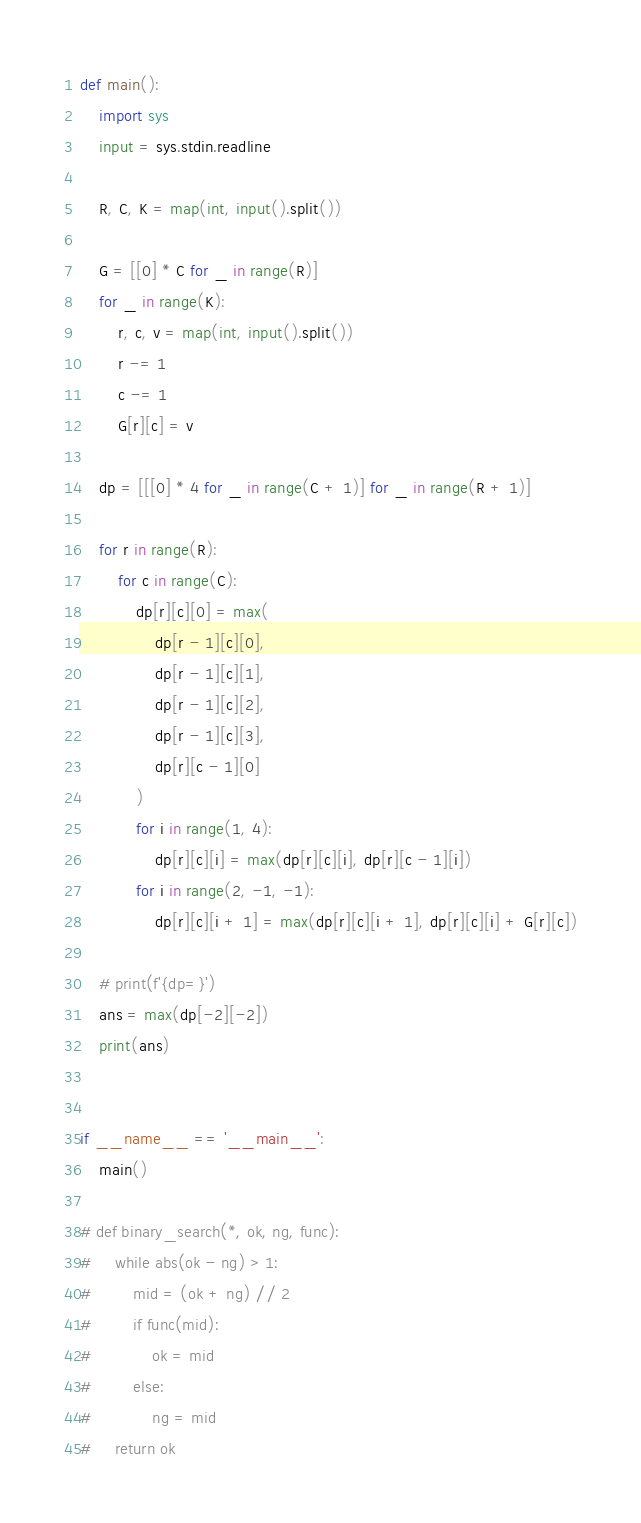Convert code to text. <code><loc_0><loc_0><loc_500><loc_500><_Python_>def main():
    import sys
    input = sys.stdin.readline

    R, C, K = map(int, input().split())

    G = [[0] * C for _ in range(R)]
    for _ in range(K):
        r, c, v = map(int, input().split())
        r -= 1
        c -= 1
        G[r][c] = v

    dp = [[[0] * 4 for _ in range(C + 1)] for _ in range(R + 1)]

    for r in range(R):
        for c in range(C):
            dp[r][c][0] = max(
                dp[r - 1][c][0],
                dp[r - 1][c][1],
                dp[r - 1][c][2],
                dp[r - 1][c][3],
                dp[r][c - 1][0]
            )
            for i in range(1, 4):
                dp[r][c][i] = max(dp[r][c][i], dp[r][c - 1][i])
            for i in range(2, -1, -1):
                dp[r][c][i + 1] = max(dp[r][c][i + 1], dp[r][c][i] + G[r][c])

    # print(f'{dp=}')
    ans = max(dp[-2][-2])
    print(ans)


if __name__ == '__main__':
    main()

# def binary_search(*, ok, ng, func):
#     while abs(ok - ng) > 1:
#         mid = (ok + ng) // 2
#         if func(mid):
#             ok = mid
#         else:
#             ng = mid
#     return ok
</code> 